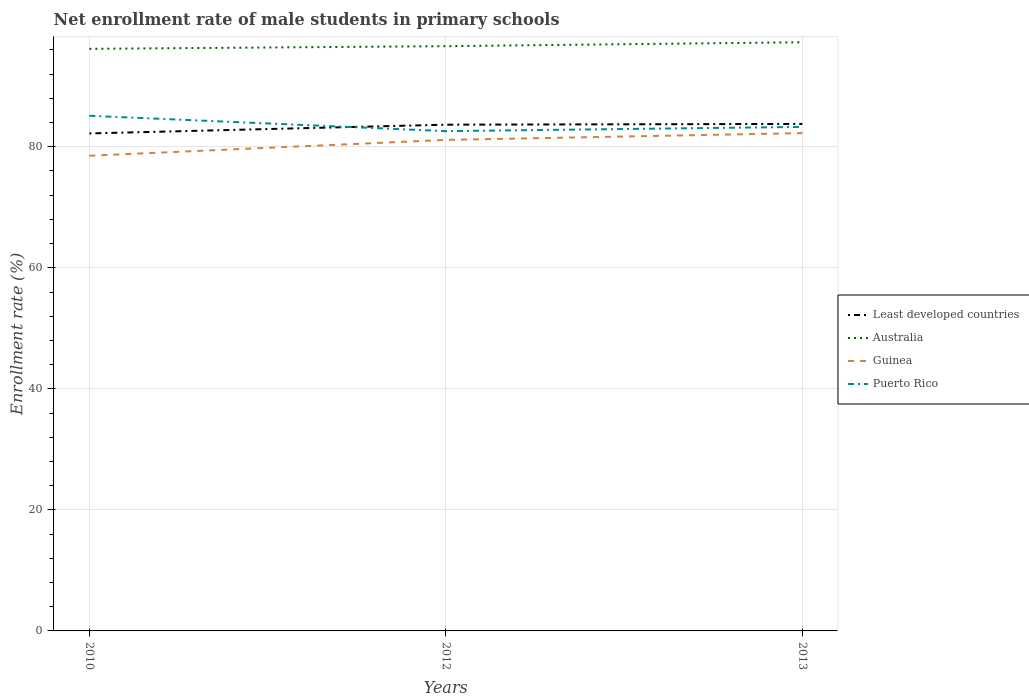Does the line corresponding to Least developed countries intersect with the line corresponding to Australia?
Your answer should be compact. No. Is the number of lines equal to the number of legend labels?
Offer a terse response. Yes. Across all years, what is the maximum net enrollment rate of male students in primary schools in Australia?
Provide a short and direct response. 96.18. What is the total net enrollment rate of male students in primary schools in Least developed countries in the graph?
Keep it short and to the point. -0.13. What is the difference between the highest and the second highest net enrollment rate of male students in primary schools in Puerto Rico?
Ensure brevity in your answer.  2.54. What is the difference between the highest and the lowest net enrollment rate of male students in primary schools in Least developed countries?
Your answer should be very brief. 2. Is the net enrollment rate of male students in primary schools in Australia strictly greater than the net enrollment rate of male students in primary schools in Puerto Rico over the years?
Offer a terse response. No. How many years are there in the graph?
Give a very brief answer. 3. Are the values on the major ticks of Y-axis written in scientific E-notation?
Keep it short and to the point. No. Does the graph contain any zero values?
Ensure brevity in your answer.  No. Does the graph contain grids?
Offer a very short reply. Yes. Where does the legend appear in the graph?
Make the answer very short. Center right. How many legend labels are there?
Ensure brevity in your answer.  4. How are the legend labels stacked?
Ensure brevity in your answer.  Vertical. What is the title of the graph?
Offer a terse response. Net enrollment rate of male students in primary schools. Does "United States" appear as one of the legend labels in the graph?
Keep it short and to the point. No. What is the label or title of the X-axis?
Offer a terse response. Years. What is the label or title of the Y-axis?
Your answer should be very brief. Enrollment rate (%). What is the Enrollment rate (%) in Least developed countries in 2010?
Provide a succinct answer. 82.2. What is the Enrollment rate (%) in Australia in 2010?
Provide a short and direct response. 96.18. What is the Enrollment rate (%) in Guinea in 2010?
Offer a very short reply. 78.52. What is the Enrollment rate (%) of Puerto Rico in 2010?
Offer a very short reply. 85.12. What is the Enrollment rate (%) of Least developed countries in 2012?
Offer a terse response. 83.65. What is the Enrollment rate (%) in Australia in 2012?
Provide a short and direct response. 96.62. What is the Enrollment rate (%) in Guinea in 2012?
Offer a very short reply. 81.13. What is the Enrollment rate (%) in Puerto Rico in 2012?
Your response must be concise. 82.58. What is the Enrollment rate (%) of Least developed countries in 2013?
Your answer should be very brief. 83.78. What is the Enrollment rate (%) of Australia in 2013?
Provide a succinct answer. 97.27. What is the Enrollment rate (%) in Guinea in 2013?
Your response must be concise. 82.26. What is the Enrollment rate (%) in Puerto Rico in 2013?
Provide a short and direct response. 83.29. Across all years, what is the maximum Enrollment rate (%) in Least developed countries?
Your answer should be compact. 83.78. Across all years, what is the maximum Enrollment rate (%) of Australia?
Make the answer very short. 97.27. Across all years, what is the maximum Enrollment rate (%) in Guinea?
Offer a very short reply. 82.26. Across all years, what is the maximum Enrollment rate (%) of Puerto Rico?
Your answer should be compact. 85.12. Across all years, what is the minimum Enrollment rate (%) of Least developed countries?
Give a very brief answer. 82.2. Across all years, what is the minimum Enrollment rate (%) of Australia?
Offer a very short reply. 96.18. Across all years, what is the minimum Enrollment rate (%) in Guinea?
Your response must be concise. 78.52. Across all years, what is the minimum Enrollment rate (%) of Puerto Rico?
Ensure brevity in your answer.  82.58. What is the total Enrollment rate (%) in Least developed countries in the graph?
Keep it short and to the point. 249.63. What is the total Enrollment rate (%) of Australia in the graph?
Your answer should be very brief. 290.08. What is the total Enrollment rate (%) of Guinea in the graph?
Provide a succinct answer. 241.91. What is the total Enrollment rate (%) in Puerto Rico in the graph?
Ensure brevity in your answer.  250.99. What is the difference between the Enrollment rate (%) of Least developed countries in 2010 and that in 2012?
Give a very brief answer. -1.45. What is the difference between the Enrollment rate (%) in Australia in 2010 and that in 2012?
Offer a terse response. -0.44. What is the difference between the Enrollment rate (%) in Guinea in 2010 and that in 2012?
Ensure brevity in your answer.  -2.62. What is the difference between the Enrollment rate (%) of Puerto Rico in 2010 and that in 2012?
Your answer should be compact. 2.54. What is the difference between the Enrollment rate (%) in Least developed countries in 2010 and that in 2013?
Your answer should be very brief. -1.57. What is the difference between the Enrollment rate (%) in Australia in 2010 and that in 2013?
Make the answer very short. -1.09. What is the difference between the Enrollment rate (%) in Guinea in 2010 and that in 2013?
Make the answer very short. -3.74. What is the difference between the Enrollment rate (%) in Puerto Rico in 2010 and that in 2013?
Your response must be concise. 1.84. What is the difference between the Enrollment rate (%) in Least developed countries in 2012 and that in 2013?
Offer a terse response. -0.13. What is the difference between the Enrollment rate (%) in Australia in 2012 and that in 2013?
Provide a short and direct response. -0.65. What is the difference between the Enrollment rate (%) of Guinea in 2012 and that in 2013?
Your answer should be compact. -1.12. What is the difference between the Enrollment rate (%) of Puerto Rico in 2012 and that in 2013?
Your answer should be very brief. -0.7. What is the difference between the Enrollment rate (%) in Least developed countries in 2010 and the Enrollment rate (%) in Australia in 2012?
Make the answer very short. -14.42. What is the difference between the Enrollment rate (%) of Least developed countries in 2010 and the Enrollment rate (%) of Guinea in 2012?
Your answer should be very brief. 1.07. What is the difference between the Enrollment rate (%) of Least developed countries in 2010 and the Enrollment rate (%) of Puerto Rico in 2012?
Provide a succinct answer. -0.38. What is the difference between the Enrollment rate (%) in Australia in 2010 and the Enrollment rate (%) in Guinea in 2012?
Your response must be concise. 15.05. What is the difference between the Enrollment rate (%) in Australia in 2010 and the Enrollment rate (%) in Puerto Rico in 2012?
Your response must be concise. 13.6. What is the difference between the Enrollment rate (%) of Guinea in 2010 and the Enrollment rate (%) of Puerto Rico in 2012?
Your answer should be very brief. -4.06. What is the difference between the Enrollment rate (%) in Least developed countries in 2010 and the Enrollment rate (%) in Australia in 2013?
Give a very brief answer. -15.07. What is the difference between the Enrollment rate (%) of Least developed countries in 2010 and the Enrollment rate (%) of Guinea in 2013?
Your answer should be compact. -0.05. What is the difference between the Enrollment rate (%) of Least developed countries in 2010 and the Enrollment rate (%) of Puerto Rico in 2013?
Your response must be concise. -1.08. What is the difference between the Enrollment rate (%) of Australia in 2010 and the Enrollment rate (%) of Guinea in 2013?
Offer a terse response. 13.93. What is the difference between the Enrollment rate (%) of Australia in 2010 and the Enrollment rate (%) of Puerto Rico in 2013?
Keep it short and to the point. 12.9. What is the difference between the Enrollment rate (%) of Guinea in 2010 and the Enrollment rate (%) of Puerto Rico in 2013?
Offer a very short reply. -4.77. What is the difference between the Enrollment rate (%) of Least developed countries in 2012 and the Enrollment rate (%) of Australia in 2013?
Provide a short and direct response. -13.62. What is the difference between the Enrollment rate (%) of Least developed countries in 2012 and the Enrollment rate (%) of Guinea in 2013?
Your response must be concise. 1.39. What is the difference between the Enrollment rate (%) in Least developed countries in 2012 and the Enrollment rate (%) in Puerto Rico in 2013?
Your answer should be compact. 0.36. What is the difference between the Enrollment rate (%) in Australia in 2012 and the Enrollment rate (%) in Guinea in 2013?
Provide a succinct answer. 14.37. What is the difference between the Enrollment rate (%) in Australia in 2012 and the Enrollment rate (%) in Puerto Rico in 2013?
Your answer should be very brief. 13.34. What is the difference between the Enrollment rate (%) of Guinea in 2012 and the Enrollment rate (%) of Puerto Rico in 2013?
Your answer should be compact. -2.15. What is the average Enrollment rate (%) of Least developed countries per year?
Provide a succinct answer. 83.21. What is the average Enrollment rate (%) of Australia per year?
Ensure brevity in your answer.  96.69. What is the average Enrollment rate (%) in Guinea per year?
Your response must be concise. 80.64. What is the average Enrollment rate (%) of Puerto Rico per year?
Keep it short and to the point. 83.66. In the year 2010, what is the difference between the Enrollment rate (%) of Least developed countries and Enrollment rate (%) of Australia?
Provide a short and direct response. -13.98. In the year 2010, what is the difference between the Enrollment rate (%) of Least developed countries and Enrollment rate (%) of Guinea?
Offer a terse response. 3.69. In the year 2010, what is the difference between the Enrollment rate (%) of Least developed countries and Enrollment rate (%) of Puerto Rico?
Ensure brevity in your answer.  -2.92. In the year 2010, what is the difference between the Enrollment rate (%) in Australia and Enrollment rate (%) in Guinea?
Provide a succinct answer. 17.67. In the year 2010, what is the difference between the Enrollment rate (%) in Australia and Enrollment rate (%) in Puerto Rico?
Your response must be concise. 11.06. In the year 2010, what is the difference between the Enrollment rate (%) of Guinea and Enrollment rate (%) of Puerto Rico?
Your answer should be compact. -6.6. In the year 2012, what is the difference between the Enrollment rate (%) in Least developed countries and Enrollment rate (%) in Australia?
Provide a succinct answer. -12.97. In the year 2012, what is the difference between the Enrollment rate (%) of Least developed countries and Enrollment rate (%) of Guinea?
Offer a very short reply. 2.52. In the year 2012, what is the difference between the Enrollment rate (%) in Least developed countries and Enrollment rate (%) in Puerto Rico?
Ensure brevity in your answer.  1.07. In the year 2012, what is the difference between the Enrollment rate (%) of Australia and Enrollment rate (%) of Guinea?
Offer a very short reply. 15.49. In the year 2012, what is the difference between the Enrollment rate (%) of Australia and Enrollment rate (%) of Puerto Rico?
Ensure brevity in your answer.  14.04. In the year 2012, what is the difference between the Enrollment rate (%) in Guinea and Enrollment rate (%) in Puerto Rico?
Make the answer very short. -1.45. In the year 2013, what is the difference between the Enrollment rate (%) of Least developed countries and Enrollment rate (%) of Australia?
Make the answer very short. -13.5. In the year 2013, what is the difference between the Enrollment rate (%) in Least developed countries and Enrollment rate (%) in Guinea?
Provide a short and direct response. 1.52. In the year 2013, what is the difference between the Enrollment rate (%) in Least developed countries and Enrollment rate (%) in Puerto Rico?
Offer a terse response. 0.49. In the year 2013, what is the difference between the Enrollment rate (%) of Australia and Enrollment rate (%) of Guinea?
Provide a succinct answer. 15.01. In the year 2013, what is the difference between the Enrollment rate (%) in Australia and Enrollment rate (%) in Puerto Rico?
Your answer should be compact. 13.98. In the year 2013, what is the difference between the Enrollment rate (%) in Guinea and Enrollment rate (%) in Puerto Rico?
Make the answer very short. -1.03. What is the ratio of the Enrollment rate (%) in Least developed countries in 2010 to that in 2012?
Keep it short and to the point. 0.98. What is the ratio of the Enrollment rate (%) of Australia in 2010 to that in 2012?
Provide a succinct answer. 1. What is the ratio of the Enrollment rate (%) in Guinea in 2010 to that in 2012?
Your answer should be compact. 0.97. What is the ratio of the Enrollment rate (%) in Puerto Rico in 2010 to that in 2012?
Give a very brief answer. 1.03. What is the ratio of the Enrollment rate (%) of Least developed countries in 2010 to that in 2013?
Offer a very short reply. 0.98. What is the ratio of the Enrollment rate (%) in Australia in 2010 to that in 2013?
Provide a short and direct response. 0.99. What is the ratio of the Enrollment rate (%) in Guinea in 2010 to that in 2013?
Provide a short and direct response. 0.95. What is the ratio of the Enrollment rate (%) in Least developed countries in 2012 to that in 2013?
Your response must be concise. 1. What is the ratio of the Enrollment rate (%) in Guinea in 2012 to that in 2013?
Your response must be concise. 0.99. What is the ratio of the Enrollment rate (%) of Puerto Rico in 2012 to that in 2013?
Your answer should be very brief. 0.99. What is the difference between the highest and the second highest Enrollment rate (%) of Least developed countries?
Offer a very short reply. 0.13. What is the difference between the highest and the second highest Enrollment rate (%) of Australia?
Offer a terse response. 0.65. What is the difference between the highest and the second highest Enrollment rate (%) of Guinea?
Offer a terse response. 1.12. What is the difference between the highest and the second highest Enrollment rate (%) of Puerto Rico?
Offer a very short reply. 1.84. What is the difference between the highest and the lowest Enrollment rate (%) in Least developed countries?
Offer a terse response. 1.57. What is the difference between the highest and the lowest Enrollment rate (%) in Australia?
Offer a terse response. 1.09. What is the difference between the highest and the lowest Enrollment rate (%) in Guinea?
Offer a very short reply. 3.74. What is the difference between the highest and the lowest Enrollment rate (%) in Puerto Rico?
Keep it short and to the point. 2.54. 